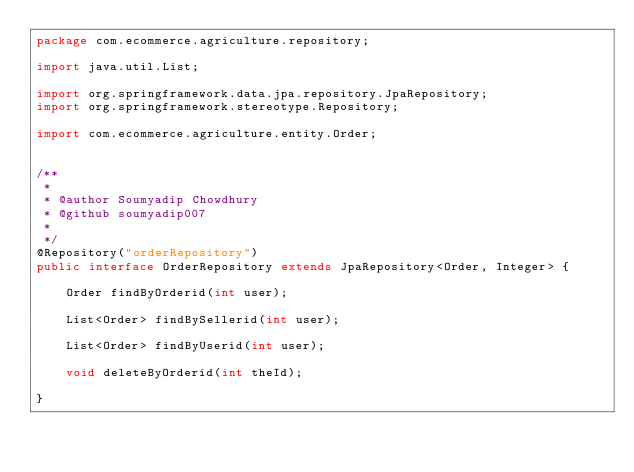Convert code to text. <code><loc_0><loc_0><loc_500><loc_500><_Java_>package com.ecommerce.agriculture.repository;

import java.util.List;

import org.springframework.data.jpa.repository.JpaRepository;
import org.springframework.stereotype.Repository;

import com.ecommerce.agriculture.entity.Order;


/**
 * 
 * @author Soumyadip Chowdhury
 * @github soumyadip007
 *
 */
@Repository("orderRepository")
public interface OrderRepository extends JpaRepository<Order, Integer> {

	Order findByOrderid(int user);
	
	List<Order> findBySellerid(int user);

	List<Order> findByUserid(int user);
	
	void deleteByOrderid(int theId);
	
}</code> 